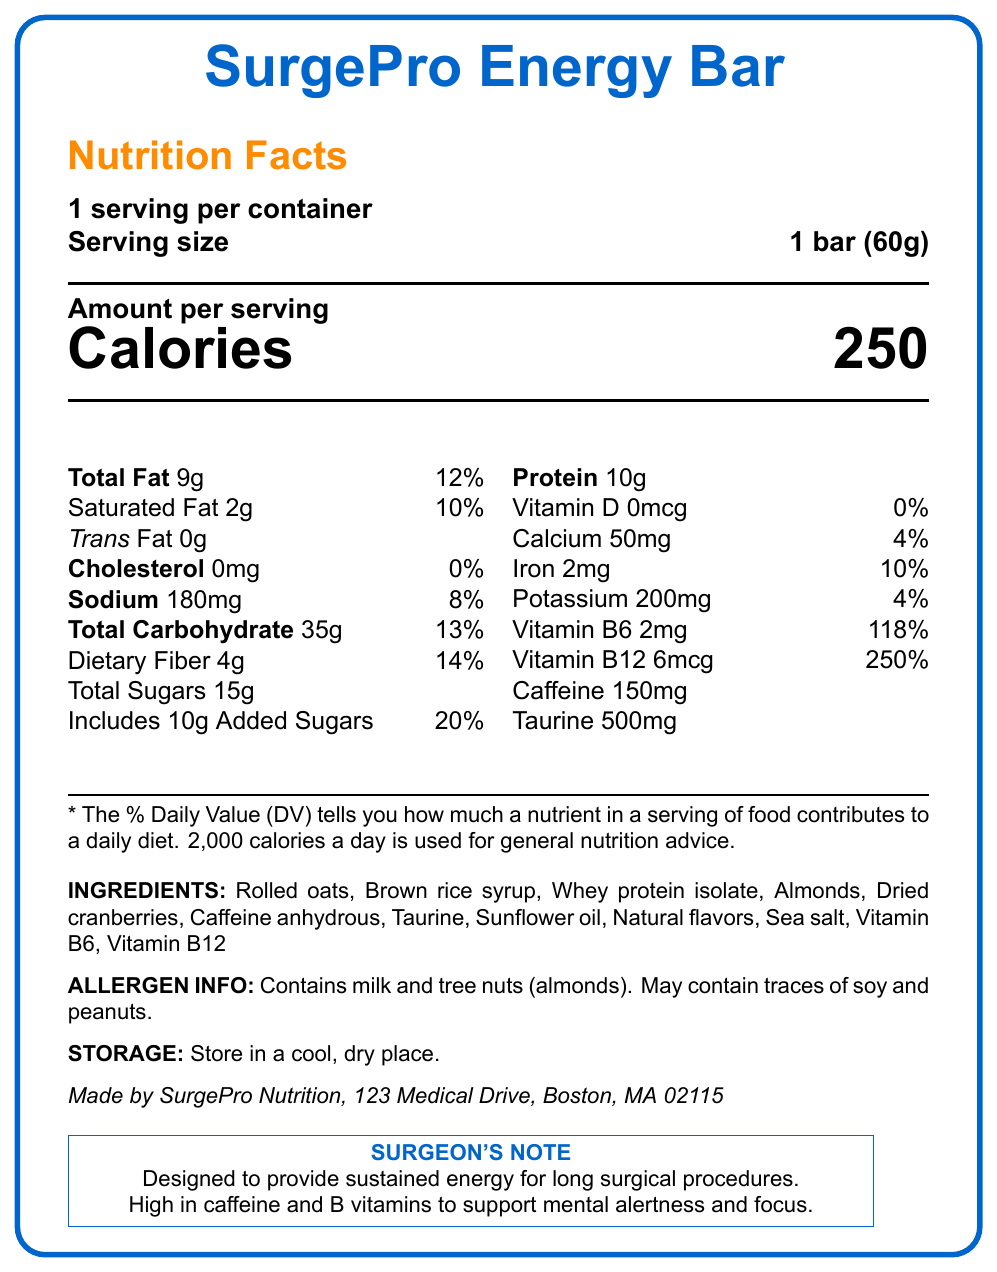what is the serving size of the SurgePro Energy Bar? The serving size is mentioned as "1 bar (60g)" on the Nutrition Facts section of the document.
Answer: 1 bar (60g) how many calories are in one serving of the SurgePro Energy Bar? The document lists "Calories" as 250 per serving.
Answer: 250 what is the amount of caffeine in the SurgePro Energy Bar? The amount of caffeine is specified as "150mg" in the nutrition facts section.
Answer: 150mg does the SurgePro Energy Bar contain any trans fat? The document states "Trans Fat 0g" indicating there is no trans fat in the bar.
Answer: No what are the main ingredients in the SurgePro Energy Bar? The ingredients list includes all these components.
Answer: Rolled oats, Brown rice syrup, Whey protein isolate, Almonds, Dried cranberries, Caffeine anhydrous, Taurine, Sunflower oil, Natural flavors, Sea salt, Vitamin B6, Vitamin B12 how much dietary fiber is present in one serving? The document lists "Dietary Fiber" as 4g per serving.
Answer: 4g what is the percentage daily value of added sugars in the SurgePro Energy Bar? The percentage daily value of added sugars is listed as "20%" in the nutrition facts section.
Answer: 20% how many grams of protein are in one bar? The document specifies "Protein 10g" per serving.
Answer: 10g is the SurgePro Energy Bar suitable for someone with a nut allergy? The allergen info states "Contains milk and tree nuts (almonds)" and may contain traces of soy and peanuts.
Answer: No what is the daily value percentage of Vitamin B12 in the SurgePro Energy Bar? The nutrition facts indicate that Vitamin B12 covers "250%" of the daily value.
Answer: 250% which vitamin has the highest percentage daily value in the SurgePro Energy Bar? A. Vitamin D B. Vitamin B6 C. Vitamin B12 D. Calcium The document shows Vitamin B12 with a daily value percentage of "250%", the highest among the listed vitamins.
Answer: C. Vitamin B12 how much sodium is in one serving of the SurgePro Energy Bar? A. 100mg B. 180mg C. 200mg D. 250mg The document mentions "Sodium 180mg" under the nutrition facts section.
Answer: B. 180mg is there any cholesterol in the SurgePro Energy Bar? (Yes/No) The document lists "Cholesterol" as "0mg" indicating there is no cholesterol.
Answer: No summarize the purpose and key features of the SurgePro Energy Bar. The summary includes the main functionalities of the SurgePro Energy Bar, emphasizing its purpose for sustained energy, key nutritional components, and specific details about its ingredients and allergen warnings.
Answer: The SurgePro Energy Bar is designed to provide sustained energy for long shifts in the operating room. It contains 150mg of caffeine, a substantial amount of protein (10g), and high levels of B vitamins to support mental alertness and focus. It is high in calories (250) and includes ingredients like rolled oats, almonds, and whey protein isolate. The bar also has specific storage instructions and allergen information. what is the glycemic index of the SurgePro Energy Bar? The document does not provide any information about the glycemic index.
Answer: Not enough information 